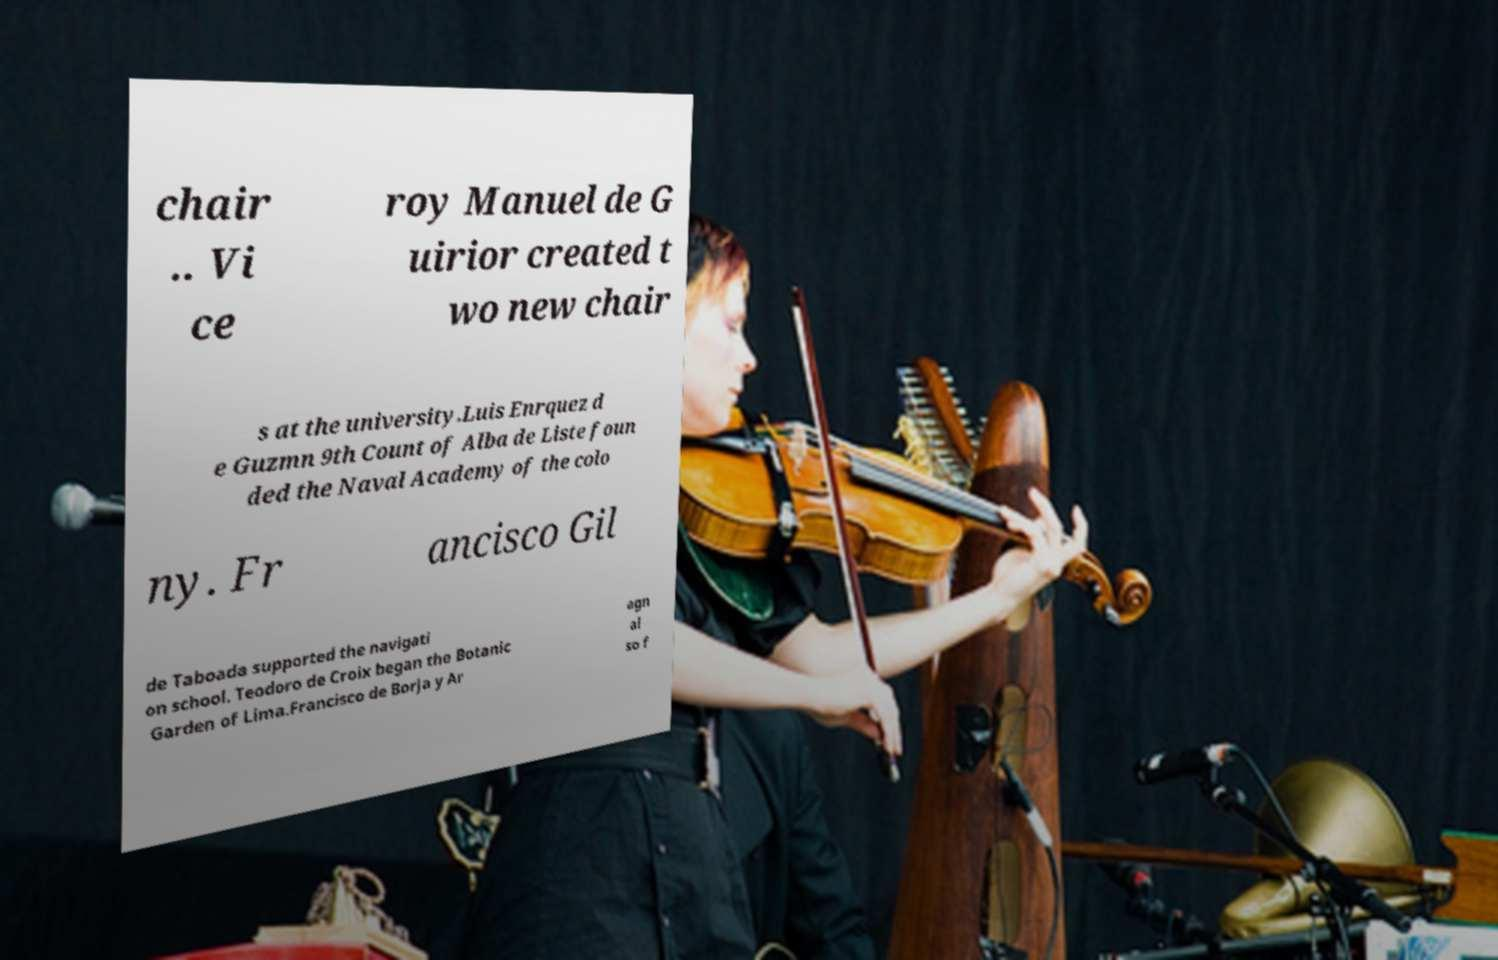Could you extract and type out the text from this image? chair .. Vi ce roy Manuel de G uirior created t wo new chair s at the university.Luis Enrquez d e Guzmn 9th Count of Alba de Liste foun ded the Naval Academy of the colo ny. Fr ancisco Gil de Taboada supported the navigati on school. Teodoro de Croix began the Botanic Garden of Lima.Francisco de Borja y Ar agn al so f 